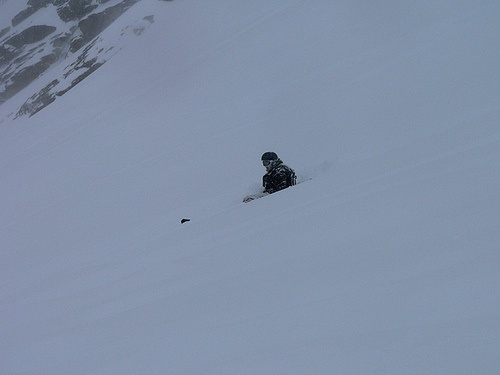Describe the objects in this image and their specific colors. I can see people in gray and black tones and backpack in gray, black, and darkblue tones in this image. 